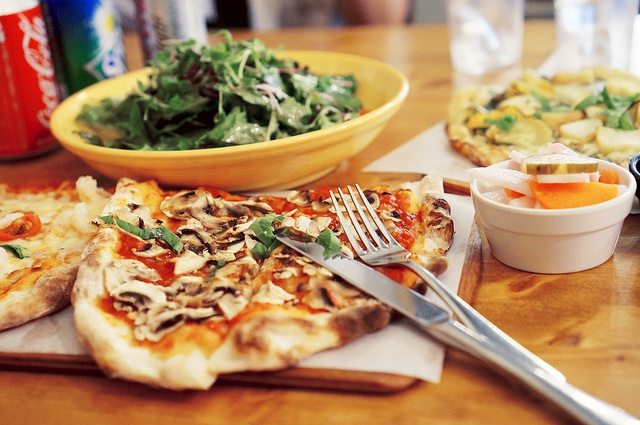Describe the objects in this image and their specific colors. I can see pizza in white, tan, red, and beige tones, dining table in white, tan, red, and orange tones, bowl in white, khaki, tan, red, and orange tones, bowl in white, lightgray, and tan tones, and pizza in white, khaki, tan, and olive tones in this image. 